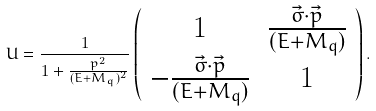Convert formula to latex. <formula><loc_0><loc_0><loc_500><loc_500>U = \frac { 1 } { 1 + \frac { p ^ { 2 } } { ( E + M _ { q } ) ^ { 2 } } } \left ( \begin{array} { c c } 1 & \frac { \vec { \sigma } \cdot \vec { p } } { ( E + M _ { q } ) } \\ - \frac { \vec { \sigma } \cdot \vec { p } } { ( E + M _ { q } ) } & 1 \end{array} \right ) .</formula> 